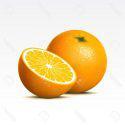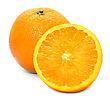The first image is the image on the left, the second image is the image on the right. Examine the images to the left and right. Is the description "There is at least six oranges that are not cut in any way." accurate? Answer yes or no. No. The first image is the image on the left, the second image is the image on the right. Examine the images to the left and right. Is the description "One of the images has exactly two uncut oranges without any other fruits present." accurate? Answer yes or no. No. 